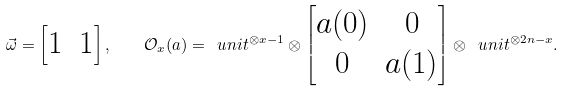Convert formula to latex. <formula><loc_0><loc_0><loc_500><loc_500>\vec { \omega } = \begin{bmatrix} 1 & 1 \end{bmatrix} , \quad \mathcal { O } _ { x } ( a ) = \ u n i t ^ { \otimes x - 1 } \otimes \begin{bmatrix} a ( 0 ) & 0 \\ 0 & a ( 1 ) \end{bmatrix} \otimes \ u n i t ^ { \otimes 2 n - x } .</formula> 